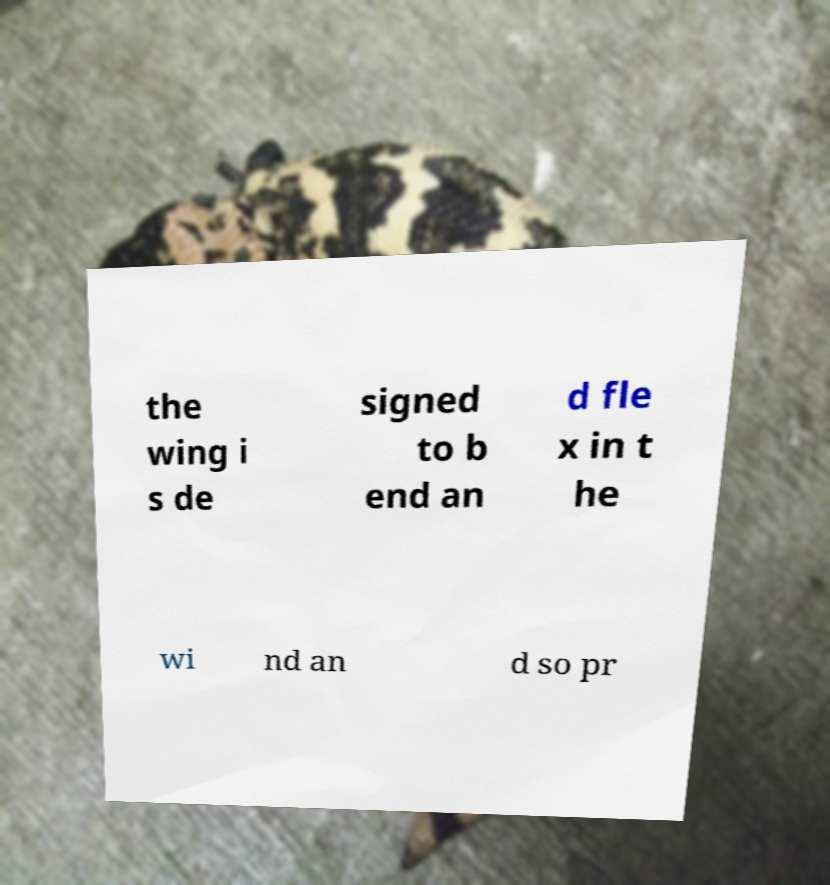What messages or text are displayed in this image? I need them in a readable, typed format. the wing i s de signed to b end an d fle x in t he wi nd an d so pr 